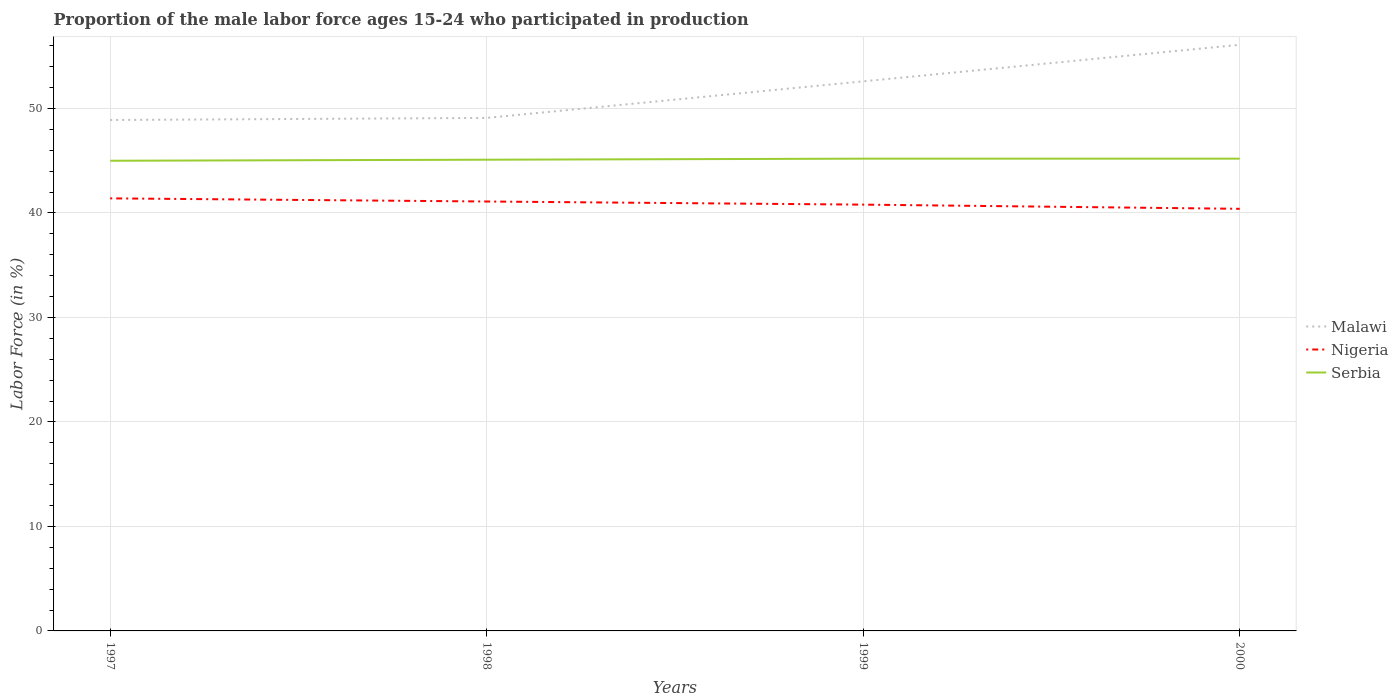How many different coloured lines are there?
Your answer should be compact. 3. Across all years, what is the maximum proportion of the male labor force who participated in production in Malawi?
Keep it short and to the point. 48.9. In which year was the proportion of the male labor force who participated in production in Serbia maximum?
Provide a succinct answer. 1997. What is the total proportion of the male labor force who participated in production in Serbia in the graph?
Provide a succinct answer. -0.1. What is the difference between the highest and the second highest proportion of the male labor force who participated in production in Malawi?
Keep it short and to the point. 7.2. Is the proportion of the male labor force who participated in production in Nigeria strictly greater than the proportion of the male labor force who participated in production in Malawi over the years?
Keep it short and to the point. Yes. How many lines are there?
Your answer should be compact. 3. Does the graph contain grids?
Provide a short and direct response. Yes. How many legend labels are there?
Ensure brevity in your answer.  3. How are the legend labels stacked?
Your answer should be very brief. Vertical. What is the title of the graph?
Keep it short and to the point. Proportion of the male labor force ages 15-24 who participated in production. What is the label or title of the X-axis?
Ensure brevity in your answer.  Years. What is the label or title of the Y-axis?
Offer a very short reply. Labor Force (in %). What is the Labor Force (in %) of Malawi in 1997?
Give a very brief answer. 48.9. What is the Labor Force (in %) in Nigeria in 1997?
Your response must be concise. 41.4. What is the Labor Force (in %) of Serbia in 1997?
Provide a short and direct response. 45. What is the Labor Force (in %) of Malawi in 1998?
Give a very brief answer. 49.1. What is the Labor Force (in %) in Nigeria in 1998?
Provide a short and direct response. 41.1. What is the Labor Force (in %) of Serbia in 1998?
Offer a terse response. 45.1. What is the Labor Force (in %) of Malawi in 1999?
Your answer should be very brief. 52.6. What is the Labor Force (in %) in Nigeria in 1999?
Make the answer very short. 40.8. What is the Labor Force (in %) in Serbia in 1999?
Offer a very short reply. 45.2. What is the Labor Force (in %) of Malawi in 2000?
Provide a short and direct response. 56.1. What is the Labor Force (in %) in Nigeria in 2000?
Offer a terse response. 40.4. What is the Labor Force (in %) in Serbia in 2000?
Your answer should be very brief. 45.2. Across all years, what is the maximum Labor Force (in %) in Malawi?
Offer a terse response. 56.1. Across all years, what is the maximum Labor Force (in %) of Nigeria?
Offer a terse response. 41.4. Across all years, what is the maximum Labor Force (in %) in Serbia?
Offer a very short reply. 45.2. Across all years, what is the minimum Labor Force (in %) in Malawi?
Provide a short and direct response. 48.9. Across all years, what is the minimum Labor Force (in %) in Nigeria?
Provide a short and direct response. 40.4. Across all years, what is the minimum Labor Force (in %) of Serbia?
Offer a terse response. 45. What is the total Labor Force (in %) of Malawi in the graph?
Ensure brevity in your answer.  206.7. What is the total Labor Force (in %) in Nigeria in the graph?
Provide a short and direct response. 163.7. What is the total Labor Force (in %) in Serbia in the graph?
Keep it short and to the point. 180.5. What is the difference between the Labor Force (in %) of Serbia in 1997 and that in 1998?
Give a very brief answer. -0.1. What is the difference between the Labor Force (in %) in Malawi in 1997 and that in 1999?
Provide a short and direct response. -3.7. What is the difference between the Labor Force (in %) of Serbia in 1997 and that in 1999?
Provide a short and direct response. -0.2. What is the difference between the Labor Force (in %) of Nigeria in 1997 and that in 2000?
Make the answer very short. 1. What is the difference between the Labor Force (in %) in Serbia in 1997 and that in 2000?
Your response must be concise. -0.2. What is the difference between the Labor Force (in %) in Malawi in 1998 and that in 1999?
Provide a short and direct response. -3.5. What is the difference between the Labor Force (in %) in Nigeria in 1998 and that in 1999?
Keep it short and to the point. 0.3. What is the difference between the Labor Force (in %) in Serbia in 1998 and that in 1999?
Your answer should be compact. -0.1. What is the difference between the Labor Force (in %) of Nigeria in 1998 and that in 2000?
Make the answer very short. 0.7. What is the difference between the Labor Force (in %) of Malawi in 1999 and that in 2000?
Provide a short and direct response. -3.5. What is the difference between the Labor Force (in %) in Nigeria in 1999 and that in 2000?
Keep it short and to the point. 0.4. What is the difference between the Labor Force (in %) of Serbia in 1999 and that in 2000?
Offer a terse response. 0. What is the difference between the Labor Force (in %) in Malawi in 1997 and the Labor Force (in %) in Nigeria in 1998?
Offer a terse response. 7.8. What is the difference between the Labor Force (in %) in Nigeria in 1997 and the Labor Force (in %) in Serbia in 1998?
Ensure brevity in your answer.  -3.7. What is the difference between the Labor Force (in %) in Malawi in 1997 and the Labor Force (in %) in Nigeria in 1999?
Give a very brief answer. 8.1. What is the difference between the Labor Force (in %) of Malawi in 1997 and the Labor Force (in %) of Nigeria in 2000?
Provide a short and direct response. 8.5. What is the difference between the Labor Force (in %) of Malawi in 1998 and the Labor Force (in %) of Nigeria in 1999?
Your answer should be compact. 8.3. What is the difference between the Labor Force (in %) in Malawi in 1998 and the Labor Force (in %) in Serbia in 1999?
Offer a terse response. 3.9. What is the difference between the Labor Force (in %) in Nigeria in 1998 and the Labor Force (in %) in Serbia in 1999?
Your answer should be very brief. -4.1. What is the difference between the Labor Force (in %) of Malawi in 1999 and the Labor Force (in %) of Nigeria in 2000?
Offer a very short reply. 12.2. What is the difference between the Labor Force (in %) in Malawi in 1999 and the Labor Force (in %) in Serbia in 2000?
Provide a short and direct response. 7.4. What is the difference between the Labor Force (in %) in Nigeria in 1999 and the Labor Force (in %) in Serbia in 2000?
Make the answer very short. -4.4. What is the average Labor Force (in %) of Malawi per year?
Offer a terse response. 51.67. What is the average Labor Force (in %) of Nigeria per year?
Your answer should be very brief. 40.92. What is the average Labor Force (in %) of Serbia per year?
Offer a terse response. 45.12. In the year 1998, what is the difference between the Labor Force (in %) of Malawi and Labor Force (in %) of Nigeria?
Your answer should be compact. 8. In the year 1998, what is the difference between the Labor Force (in %) in Malawi and Labor Force (in %) in Serbia?
Keep it short and to the point. 4. In the year 2000, what is the difference between the Labor Force (in %) of Malawi and Labor Force (in %) of Nigeria?
Make the answer very short. 15.7. What is the ratio of the Labor Force (in %) in Nigeria in 1997 to that in 1998?
Provide a short and direct response. 1.01. What is the ratio of the Labor Force (in %) of Serbia in 1997 to that in 1998?
Your response must be concise. 1. What is the ratio of the Labor Force (in %) in Malawi in 1997 to that in 1999?
Provide a short and direct response. 0.93. What is the ratio of the Labor Force (in %) in Nigeria in 1997 to that in 1999?
Offer a very short reply. 1.01. What is the ratio of the Labor Force (in %) of Malawi in 1997 to that in 2000?
Provide a short and direct response. 0.87. What is the ratio of the Labor Force (in %) of Nigeria in 1997 to that in 2000?
Keep it short and to the point. 1.02. What is the ratio of the Labor Force (in %) of Serbia in 1997 to that in 2000?
Offer a very short reply. 1. What is the ratio of the Labor Force (in %) of Malawi in 1998 to that in 1999?
Keep it short and to the point. 0.93. What is the ratio of the Labor Force (in %) in Nigeria in 1998 to that in 1999?
Make the answer very short. 1.01. What is the ratio of the Labor Force (in %) in Serbia in 1998 to that in 1999?
Give a very brief answer. 1. What is the ratio of the Labor Force (in %) in Malawi in 1998 to that in 2000?
Provide a short and direct response. 0.88. What is the ratio of the Labor Force (in %) of Nigeria in 1998 to that in 2000?
Provide a succinct answer. 1.02. What is the ratio of the Labor Force (in %) in Malawi in 1999 to that in 2000?
Offer a terse response. 0.94. What is the ratio of the Labor Force (in %) of Nigeria in 1999 to that in 2000?
Keep it short and to the point. 1.01. What is the difference between the highest and the second highest Labor Force (in %) in Malawi?
Provide a short and direct response. 3.5. What is the difference between the highest and the second highest Labor Force (in %) of Nigeria?
Your response must be concise. 0.3. What is the difference between the highest and the second highest Labor Force (in %) in Serbia?
Your response must be concise. 0. What is the difference between the highest and the lowest Labor Force (in %) in Nigeria?
Give a very brief answer. 1. What is the difference between the highest and the lowest Labor Force (in %) in Serbia?
Provide a succinct answer. 0.2. 